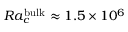<formula> <loc_0><loc_0><loc_500><loc_500>R a _ { c } ^ { b u l k } \approx 1 . 5 \times 1 0 ^ { 6 }</formula> 